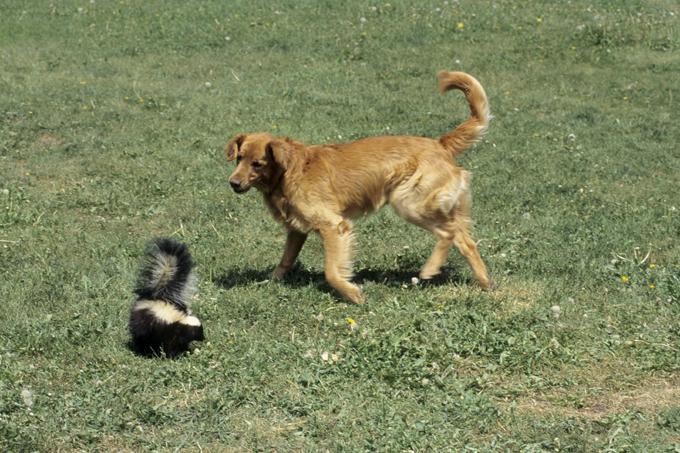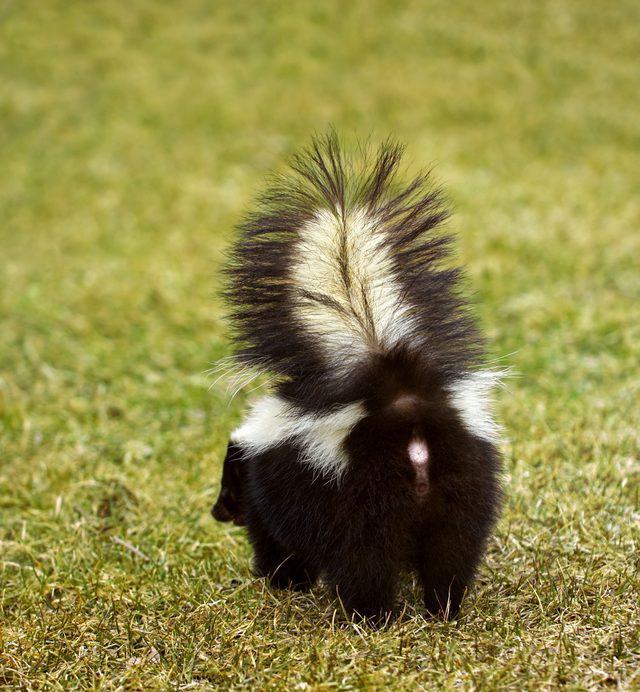The first image is the image on the left, the second image is the image on the right. Evaluate the accuracy of this statement regarding the images: "In the left image there is a skunk and one other animal.". Is it true? Answer yes or no. Yes. The first image is the image on the left, the second image is the image on the right. For the images shown, is this caption "The left image shows a reddish-brown canine facing the tail end of a skunk, and the right image features one solitary skunk that is not in profile." true? Answer yes or no. Yes. 